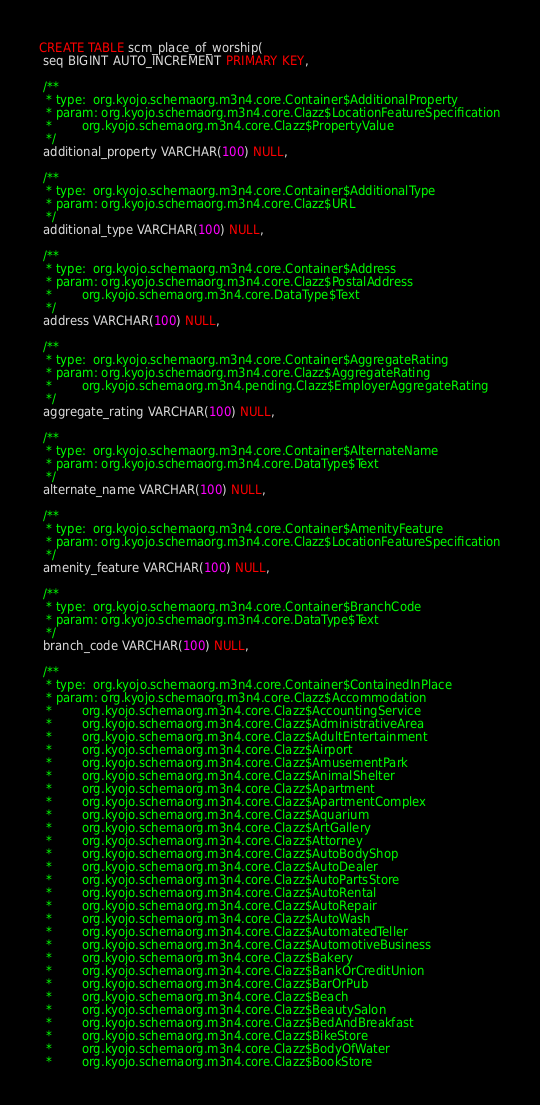<code> <loc_0><loc_0><loc_500><loc_500><_SQL_>CREATE TABLE scm_place_of_worship(
 seq BIGINT AUTO_INCREMENT PRIMARY KEY,

 /**
  * type:  org.kyojo.schemaorg.m3n4.core.Container$AdditionalProperty
  * param: org.kyojo.schemaorg.m3n4.core.Clazz$LocationFeatureSpecification
  *        org.kyojo.schemaorg.m3n4.core.Clazz$PropertyValue
  */
 additional_property VARCHAR(100) NULL,

 /**
  * type:  org.kyojo.schemaorg.m3n4.core.Container$AdditionalType
  * param: org.kyojo.schemaorg.m3n4.core.Clazz$URL
  */
 additional_type VARCHAR(100) NULL,

 /**
  * type:  org.kyojo.schemaorg.m3n4.core.Container$Address
  * param: org.kyojo.schemaorg.m3n4.core.Clazz$PostalAddress
  *        org.kyojo.schemaorg.m3n4.core.DataType$Text
  */
 address VARCHAR(100) NULL,

 /**
  * type:  org.kyojo.schemaorg.m3n4.core.Container$AggregateRating
  * param: org.kyojo.schemaorg.m3n4.core.Clazz$AggregateRating
  *        org.kyojo.schemaorg.m3n4.pending.Clazz$EmployerAggregateRating
  */
 aggregate_rating VARCHAR(100) NULL,

 /**
  * type:  org.kyojo.schemaorg.m3n4.core.Container$AlternateName
  * param: org.kyojo.schemaorg.m3n4.core.DataType$Text
  */
 alternate_name VARCHAR(100) NULL,

 /**
  * type:  org.kyojo.schemaorg.m3n4.core.Container$AmenityFeature
  * param: org.kyojo.schemaorg.m3n4.core.Clazz$LocationFeatureSpecification
  */
 amenity_feature VARCHAR(100) NULL,

 /**
  * type:  org.kyojo.schemaorg.m3n4.core.Container$BranchCode
  * param: org.kyojo.schemaorg.m3n4.core.DataType$Text
  */
 branch_code VARCHAR(100) NULL,

 /**
  * type:  org.kyojo.schemaorg.m3n4.core.Container$ContainedInPlace
  * param: org.kyojo.schemaorg.m3n4.core.Clazz$Accommodation
  *        org.kyojo.schemaorg.m3n4.core.Clazz$AccountingService
  *        org.kyojo.schemaorg.m3n4.core.Clazz$AdministrativeArea
  *        org.kyojo.schemaorg.m3n4.core.Clazz$AdultEntertainment
  *        org.kyojo.schemaorg.m3n4.core.Clazz$Airport
  *        org.kyojo.schemaorg.m3n4.core.Clazz$AmusementPark
  *        org.kyojo.schemaorg.m3n4.core.Clazz$AnimalShelter
  *        org.kyojo.schemaorg.m3n4.core.Clazz$Apartment
  *        org.kyojo.schemaorg.m3n4.core.Clazz$ApartmentComplex
  *        org.kyojo.schemaorg.m3n4.core.Clazz$Aquarium
  *        org.kyojo.schemaorg.m3n4.core.Clazz$ArtGallery
  *        org.kyojo.schemaorg.m3n4.core.Clazz$Attorney
  *        org.kyojo.schemaorg.m3n4.core.Clazz$AutoBodyShop
  *        org.kyojo.schemaorg.m3n4.core.Clazz$AutoDealer
  *        org.kyojo.schemaorg.m3n4.core.Clazz$AutoPartsStore
  *        org.kyojo.schemaorg.m3n4.core.Clazz$AutoRental
  *        org.kyojo.schemaorg.m3n4.core.Clazz$AutoRepair
  *        org.kyojo.schemaorg.m3n4.core.Clazz$AutoWash
  *        org.kyojo.schemaorg.m3n4.core.Clazz$AutomatedTeller
  *        org.kyojo.schemaorg.m3n4.core.Clazz$AutomotiveBusiness
  *        org.kyojo.schemaorg.m3n4.core.Clazz$Bakery
  *        org.kyojo.schemaorg.m3n4.core.Clazz$BankOrCreditUnion
  *        org.kyojo.schemaorg.m3n4.core.Clazz$BarOrPub
  *        org.kyojo.schemaorg.m3n4.core.Clazz$Beach
  *        org.kyojo.schemaorg.m3n4.core.Clazz$BeautySalon
  *        org.kyojo.schemaorg.m3n4.core.Clazz$BedAndBreakfast
  *        org.kyojo.schemaorg.m3n4.core.Clazz$BikeStore
  *        org.kyojo.schemaorg.m3n4.core.Clazz$BodyOfWater
  *        org.kyojo.schemaorg.m3n4.core.Clazz$BookStore</code> 